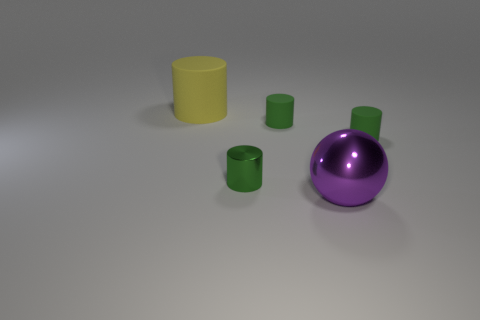What number of things are either cyan rubber cubes or big yellow rubber cylinders? The image contains two cyan rubber cubes and one big yellow rubber cylinder, so the total number of objects that meet the criteria is three. 